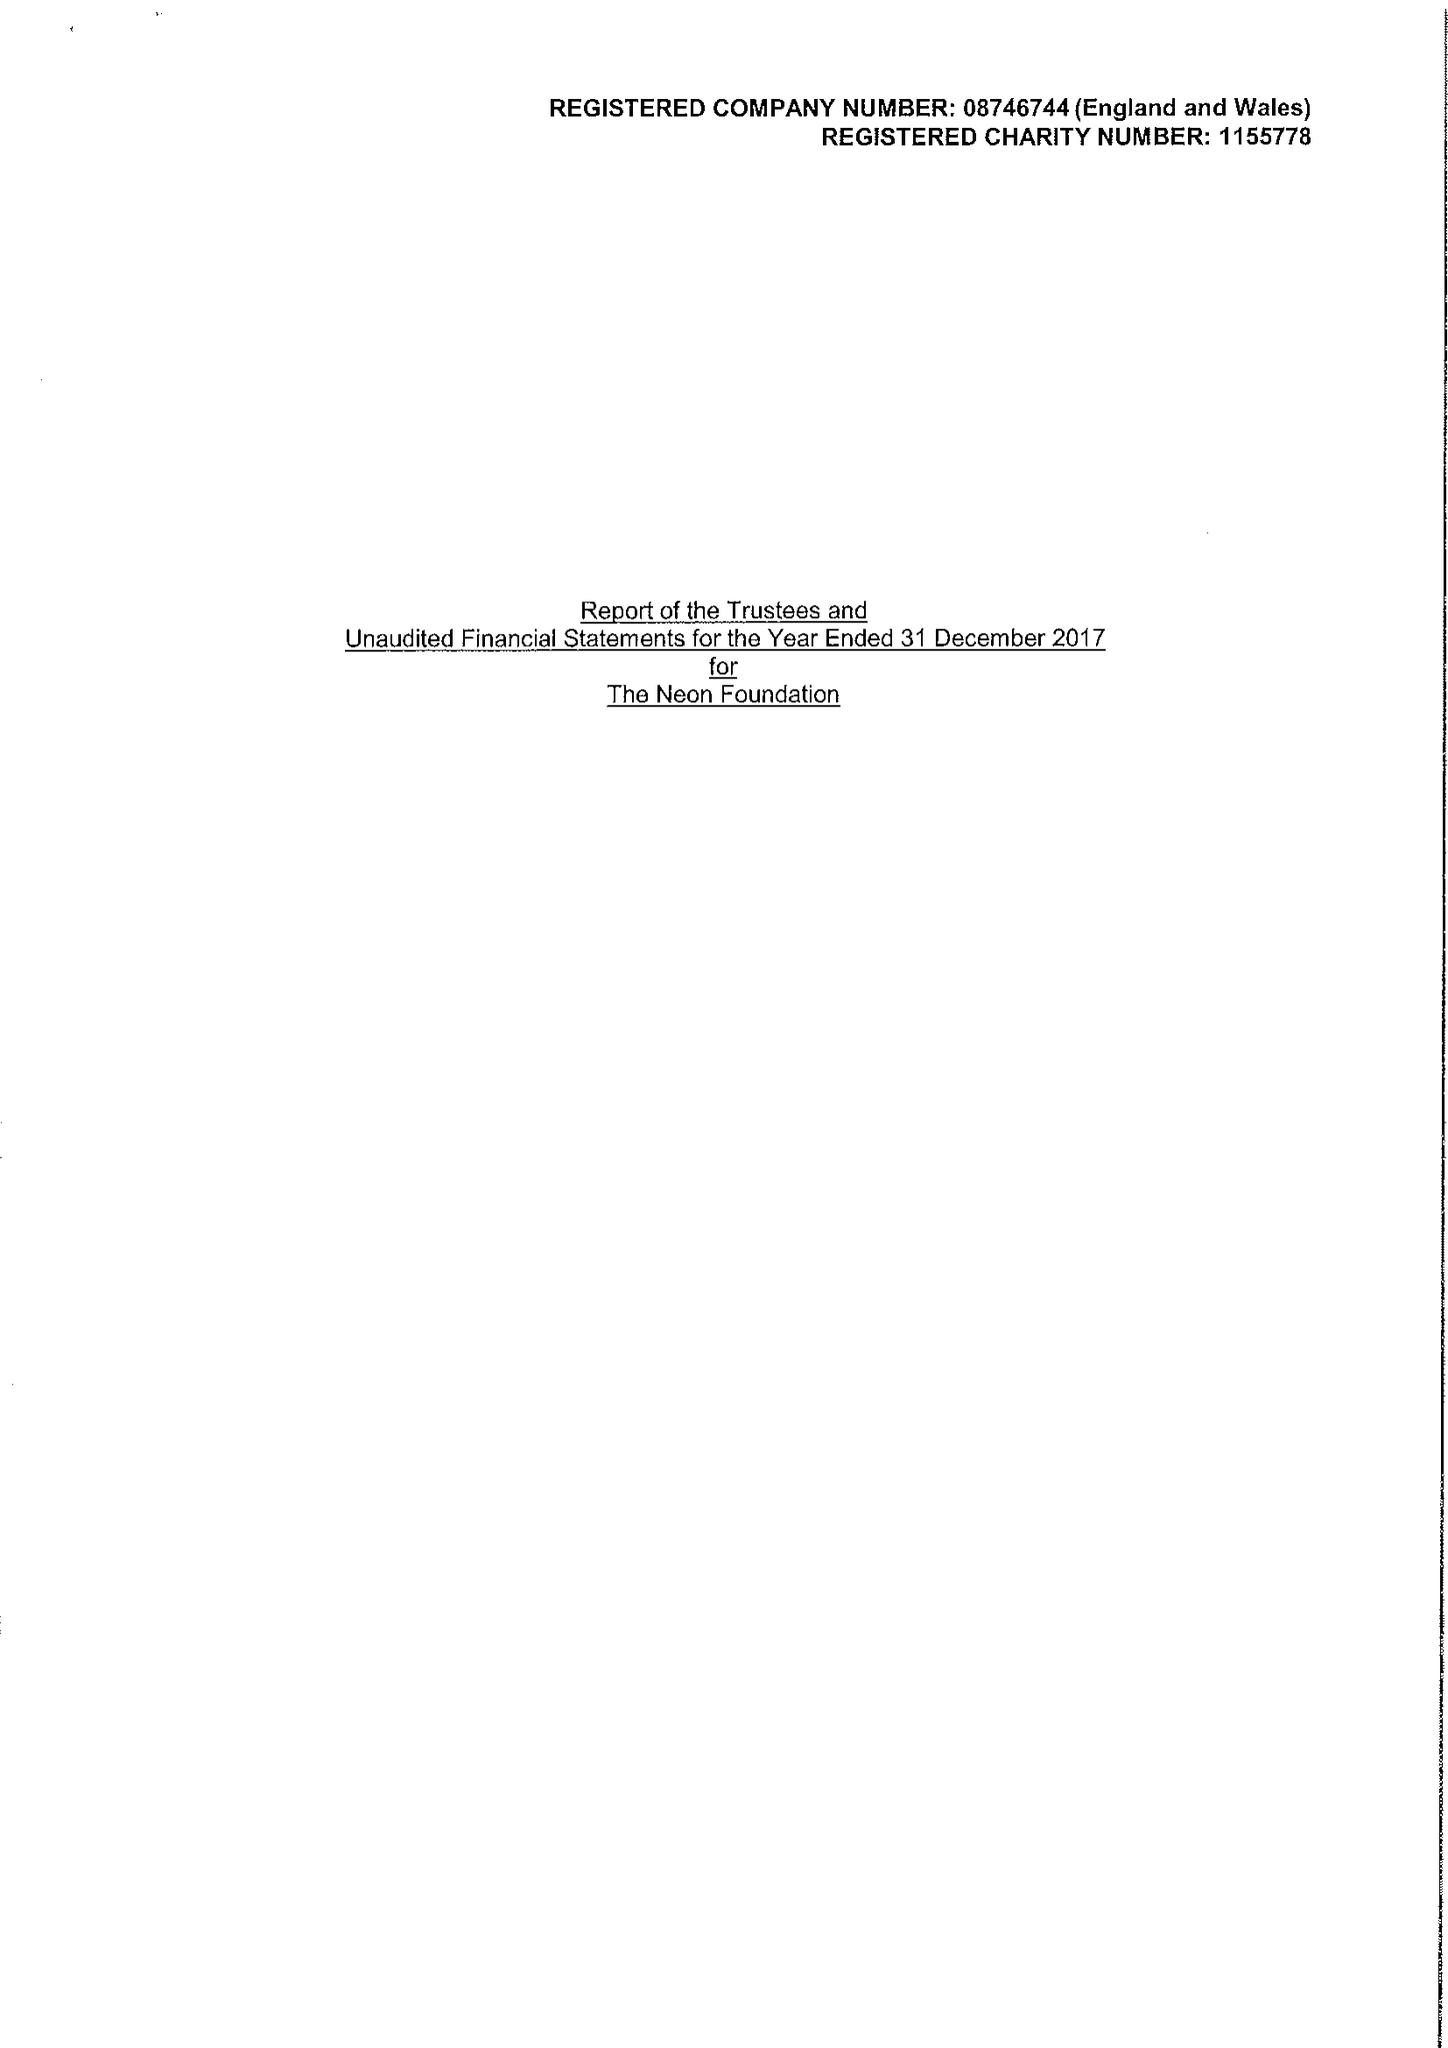What is the value for the spending_annually_in_british_pounds?
Answer the question using a single word or phrase. 2050036.00 